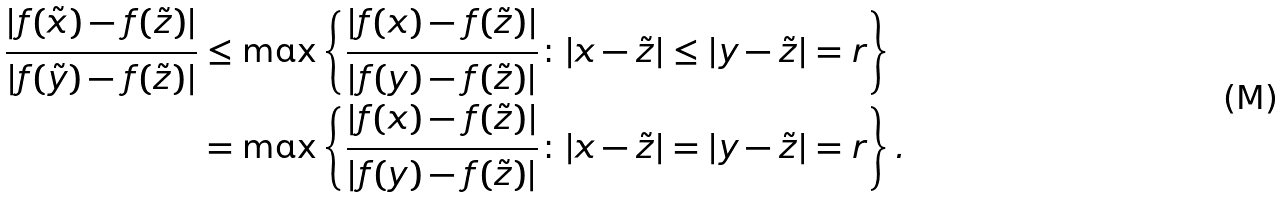Convert formula to latex. <formula><loc_0><loc_0><loc_500><loc_500>\frac { | f ( \tilde { x } ) - f ( \tilde { z } ) | } { | f ( \tilde { y } ) - f ( \tilde { z } ) | } & \leq \max \left \{ \frac { | f ( x ) - f ( \tilde { z } ) | } { | f ( y ) - f ( \tilde { z } ) | } \colon | x - \tilde { z } | \leq | y - \tilde { z } | = r \right \} \\ & = \max \left \{ \frac { | f ( x ) - f ( \tilde { z } ) | } { | f ( y ) - f ( \tilde { z } ) | } \colon | x - \tilde { z } | = | y - \tilde { z } | = r \right \} .</formula> 